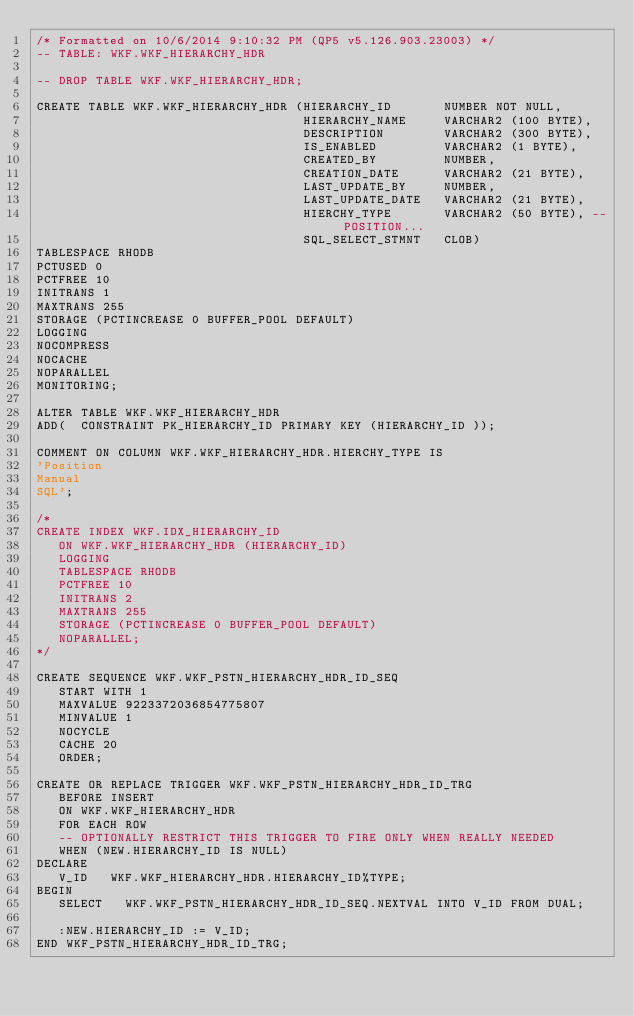<code> <loc_0><loc_0><loc_500><loc_500><_SQL_>/* Formatted on 10/6/2014 9:10:32 PM (QP5 v5.126.903.23003) */
-- TABLE: WKF.WKF_HIERARCHY_HDR

-- DROP TABLE WKF.WKF_HIERARCHY_HDR;

CREATE TABLE WKF.WKF_HIERARCHY_HDR (HIERARCHY_ID       NUMBER NOT NULL,
                                    HIERARCHY_NAME     VARCHAR2 (100 BYTE),
                                    DESCRIPTION        VARCHAR2 (300 BYTE),
                                    IS_ENABLED         VARCHAR2 (1 BYTE),
                                    CREATED_BY         NUMBER,
                                    CREATION_DATE      VARCHAR2 (21 BYTE),
                                    LAST_UPDATE_BY     NUMBER,
                                    LAST_UPDATE_DATE   VARCHAR2 (21 BYTE),
                                    HIERCHY_TYPE       VARCHAR2 (50 BYTE), -- POSITION...
                                    SQL_SELECT_STMNT   CLOB)
TABLESPACE RHODB
PCTUSED 0
PCTFREE 10
INITRANS 1
MAXTRANS 255
STORAGE (PCTINCREASE 0 BUFFER_POOL DEFAULT)
LOGGING
NOCOMPRESS
NOCACHE
NOPARALLEL
MONITORING;

ALTER TABLE WKF.WKF_HIERARCHY_HDR
ADD(  CONSTRAINT PK_HIERARCHY_ID PRIMARY KEY (HIERARCHY_ID ));

COMMENT ON COLUMN WKF.WKF_HIERARCHY_HDR.HIERCHY_TYPE IS
'Position
Manual
SQL';

/*
CREATE INDEX WKF.IDX_HIERARCHY_ID
   ON WKF.WKF_HIERARCHY_HDR (HIERARCHY_ID)
   LOGGING
   TABLESPACE RHODB
   PCTFREE 10
   INITRANS 2
   MAXTRANS 255
   STORAGE (PCTINCREASE 0 BUFFER_POOL DEFAULT)
   NOPARALLEL;
*/

CREATE SEQUENCE WKF.WKF_PSTN_HIERARCHY_HDR_ID_SEQ
   START WITH 1
   MAXVALUE 9223372036854775807
   MINVALUE 1
   NOCYCLE
   CACHE 20
   ORDER;

CREATE OR REPLACE TRIGGER WKF.WKF_PSTN_HIERARCHY_HDR_ID_TRG
   BEFORE INSERT
   ON WKF.WKF_HIERARCHY_HDR
   FOR EACH ROW
   -- OPTIONALLY RESTRICT THIS TRIGGER TO FIRE ONLY WHEN REALLY NEEDED
   WHEN (NEW.HIERARCHY_ID IS NULL)
DECLARE
   V_ID   WKF.WKF_HIERARCHY_HDR.HIERARCHY_ID%TYPE;
BEGIN
   SELECT   WKF.WKF_PSTN_HIERARCHY_HDR_ID_SEQ.NEXTVAL INTO V_ID FROM DUAL;

   :NEW.HIERARCHY_ID := V_ID;
END WKF_PSTN_HIERARCHY_HDR_ID_TRG;</code> 